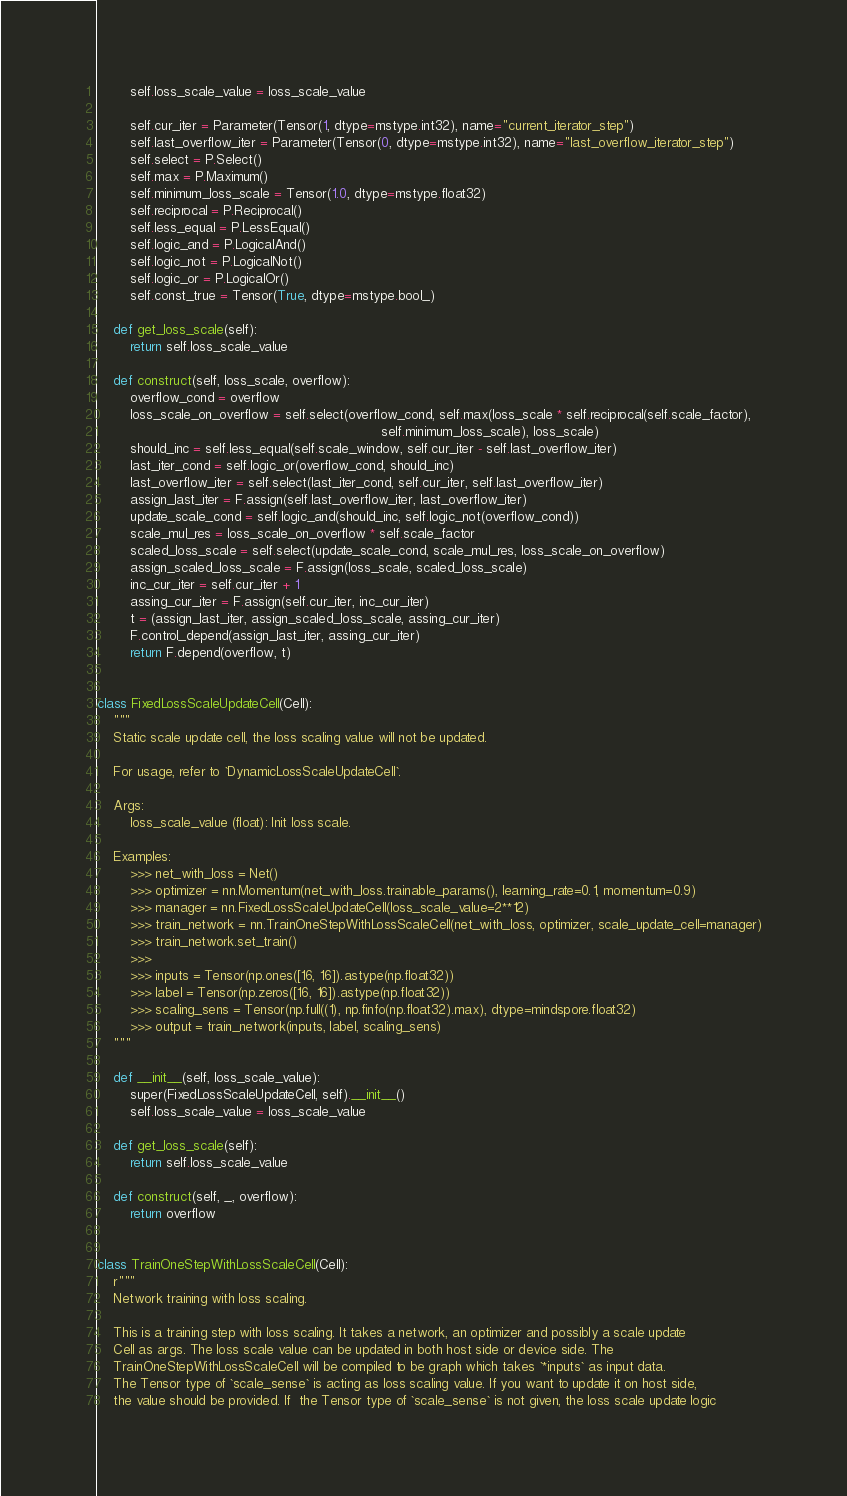Convert code to text. <code><loc_0><loc_0><loc_500><loc_500><_Python_>        self.loss_scale_value = loss_scale_value

        self.cur_iter = Parameter(Tensor(1, dtype=mstype.int32), name="current_iterator_step")
        self.last_overflow_iter = Parameter(Tensor(0, dtype=mstype.int32), name="last_overflow_iterator_step")
        self.select = P.Select()
        self.max = P.Maximum()
        self.minimum_loss_scale = Tensor(1.0, dtype=mstype.float32)
        self.reciprocal = P.Reciprocal()
        self.less_equal = P.LessEqual()
        self.logic_and = P.LogicalAnd()
        self.logic_not = P.LogicalNot()
        self.logic_or = P.LogicalOr()
        self.const_true = Tensor(True, dtype=mstype.bool_)

    def get_loss_scale(self):
        return self.loss_scale_value

    def construct(self, loss_scale, overflow):
        overflow_cond = overflow
        loss_scale_on_overflow = self.select(overflow_cond, self.max(loss_scale * self.reciprocal(self.scale_factor),
                                                                     self.minimum_loss_scale), loss_scale)
        should_inc = self.less_equal(self.scale_window, self.cur_iter - self.last_overflow_iter)
        last_iter_cond = self.logic_or(overflow_cond, should_inc)
        last_overflow_iter = self.select(last_iter_cond, self.cur_iter, self.last_overflow_iter)
        assign_last_iter = F.assign(self.last_overflow_iter, last_overflow_iter)
        update_scale_cond = self.logic_and(should_inc, self.logic_not(overflow_cond))
        scale_mul_res = loss_scale_on_overflow * self.scale_factor
        scaled_loss_scale = self.select(update_scale_cond, scale_mul_res, loss_scale_on_overflow)
        assign_scaled_loss_scale = F.assign(loss_scale, scaled_loss_scale)
        inc_cur_iter = self.cur_iter + 1
        assing_cur_iter = F.assign(self.cur_iter, inc_cur_iter)
        t = (assign_last_iter, assign_scaled_loss_scale, assing_cur_iter)
        F.control_depend(assign_last_iter, assing_cur_iter)
        return F.depend(overflow, t)


class FixedLossScaleUpdateCell(Cell):
    """
    Static scale update cell, the loss scaling value will not be updated.

    For usage, refer to `DynamicLossScaleUpdateCell`.

    Args:
        loss_scale_value (float): Init loss scale.

    Examples:
        >>> net_with_loss = Net()
        >>> optimizer = nn.Momentum(net_with_loss.trainable_params(), learning_rate=0.1, momentum=0.9)
        >>> manager = nn.FixedLossScaleUpdateCell(loss_scale_value=2**12)
        >>> train_network = nn.TrainOneStepWithLossScaleCell(net_with_loss, optimizer, scale_update_cell=manager)
        >>> train_network.set_train()
        >>>
        >>> inputs = Tensor(np.ones([16, 16]).astype(np.float32))
        >>> label = Tensor(np.zeros([16, 16]).astype(np.float32))
        >>> scaling_sens = Tensor(np.full((1), np.finfo(np.float32).max), dtype=mindspore.float32)
        >>> output = train_network(inputs, label, scaling_sens)
    """

    def __init__(self, loss_scale_value):
        super(FixedLossScaleUpdateCell, self).__init__()
        self.loss_scale_value = loss_scale_value

    def get_loss_scale(self):
        return self.loss_scale_value

    def construct(self, _, overflow):
        return overflow


class TrainOneStepWithLossScaleCell(Cell):
    r"""
    Network training with loss scaling.

    This is a training step with loss scaling. It takes a network, an optimizer and possibly a scale update
    Cell as args. The loss scale value can be updated in both host side or device side. The
    TrainOneStepWithLossScaleCell will be compiled to be graph which takes `*inputs` as input data.
    The Tensor type of `scale_sense` is acting as loss scaling value. If you want to update it on host side,
    the value should be provided. If  the Tensor type of `scale_sense` is not given, the loss scale update logic</code> 